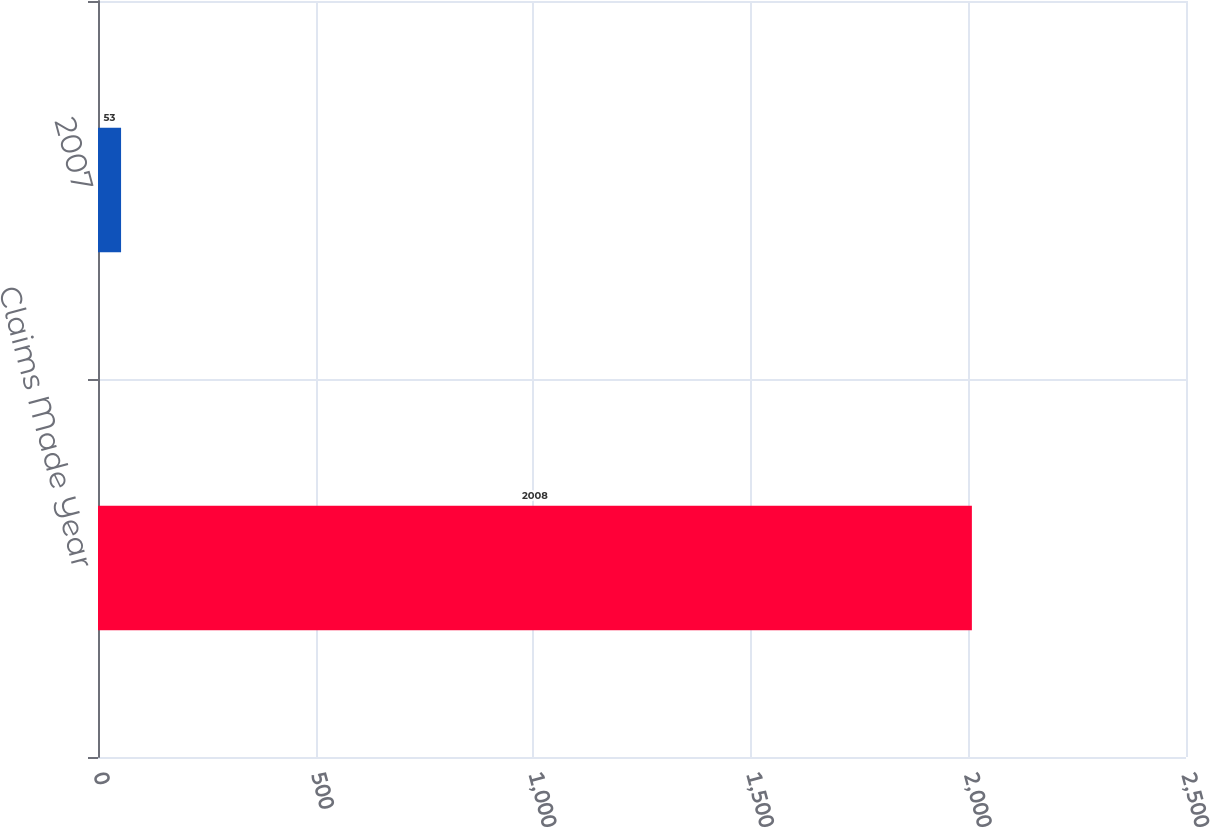Convert chart. <chart><loc_0><loc_0><loc_500><loc_500><bar_chart><fcel>Claims Made Year<fcel>2007<nl><fcel>2008<fcel>53<nl></chart> 